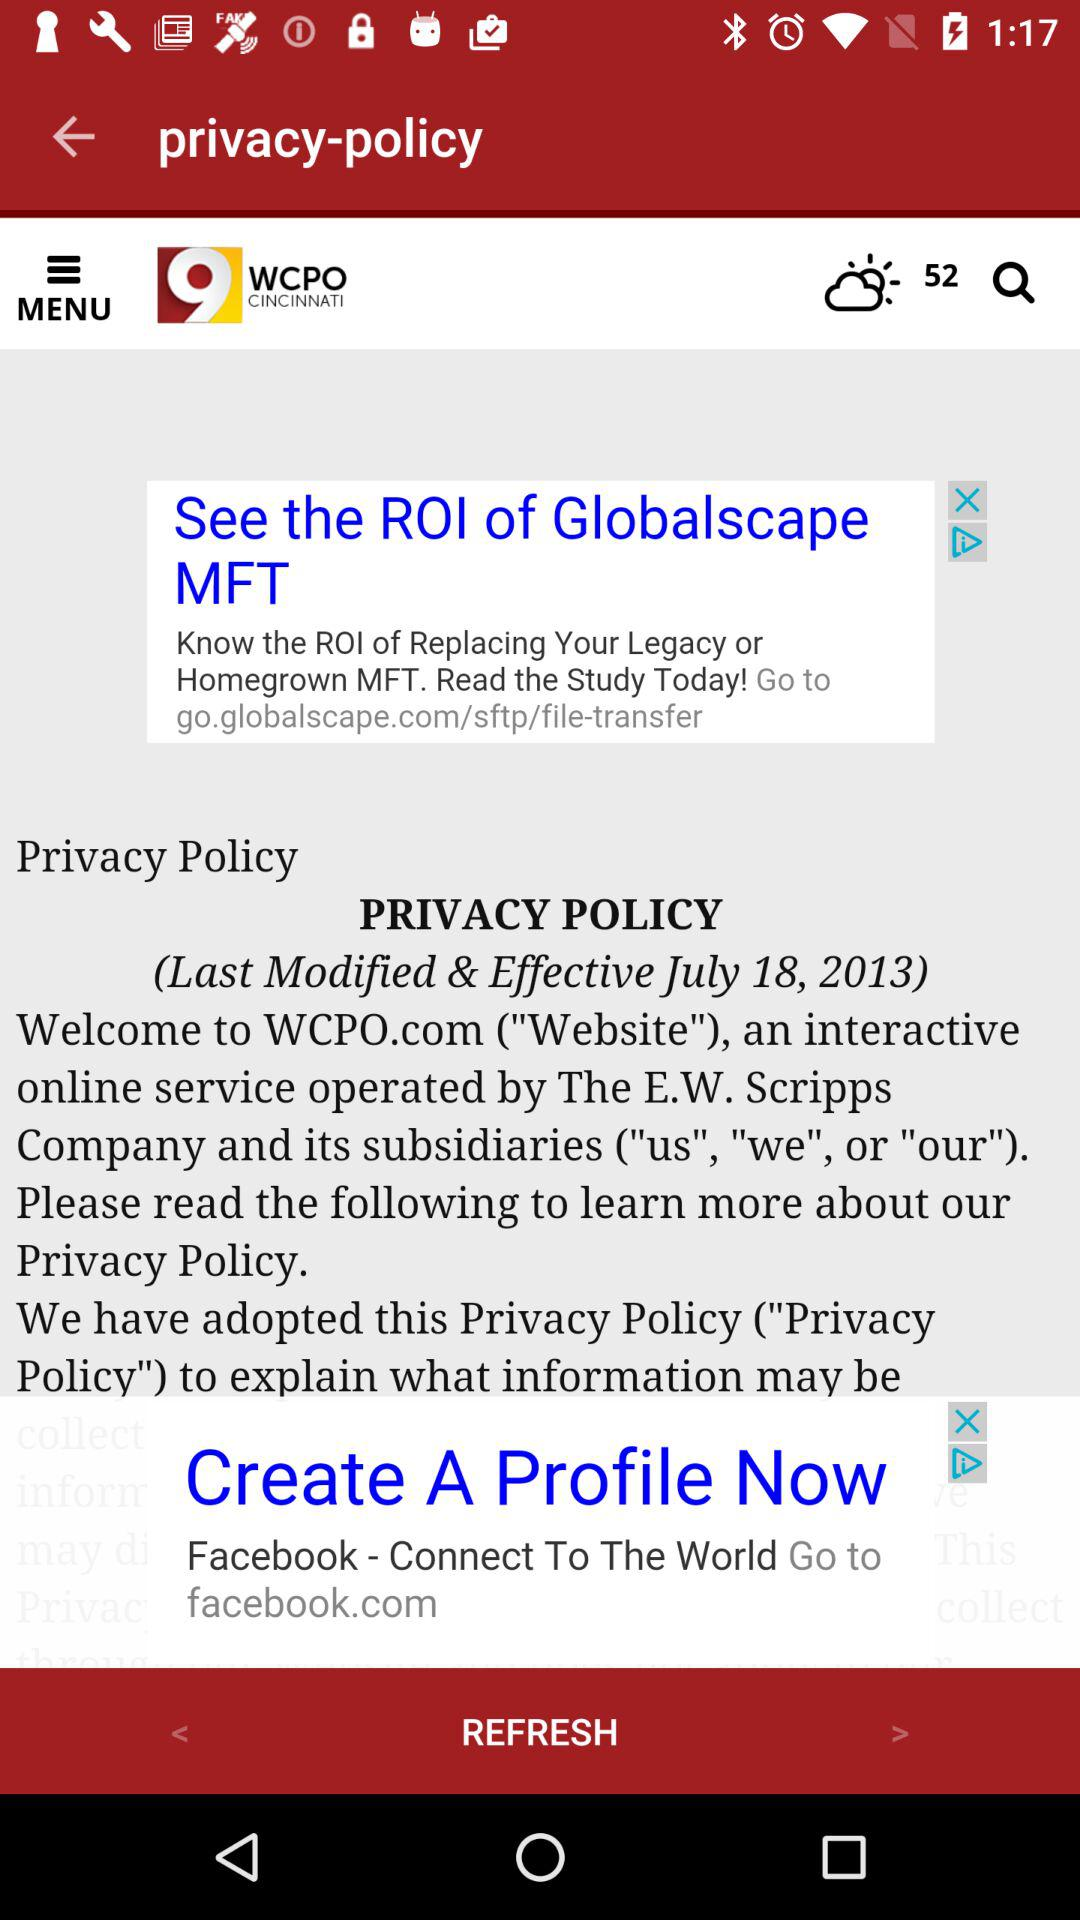What is the temperature? The temperature is 52. 